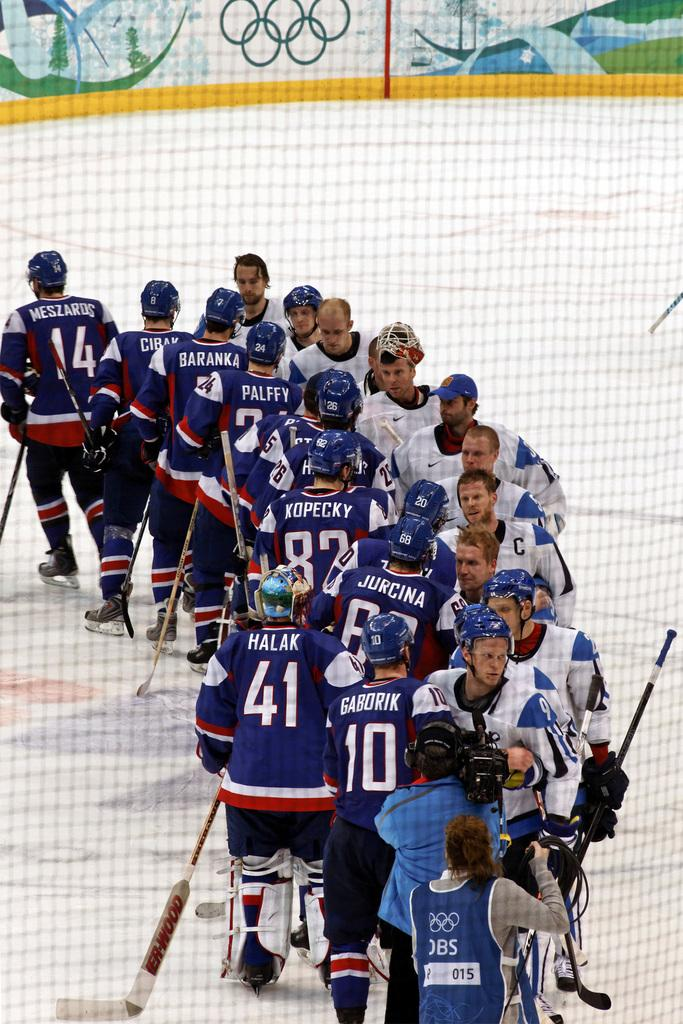Provide a one-sentence caption for the provided image. Hockey players in white shirts and Reebok sponsored helmets are lined up to shake the hands of the opposing team. 